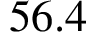Convert formula to latex. <formula><loc_0><loc_0><loc_500><loc_500>5 6 . 4</formula> 